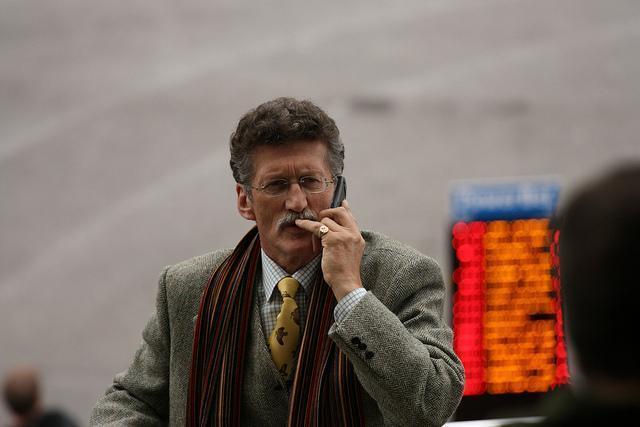How many people are in the picture?
Give a very brief answer. 3. 